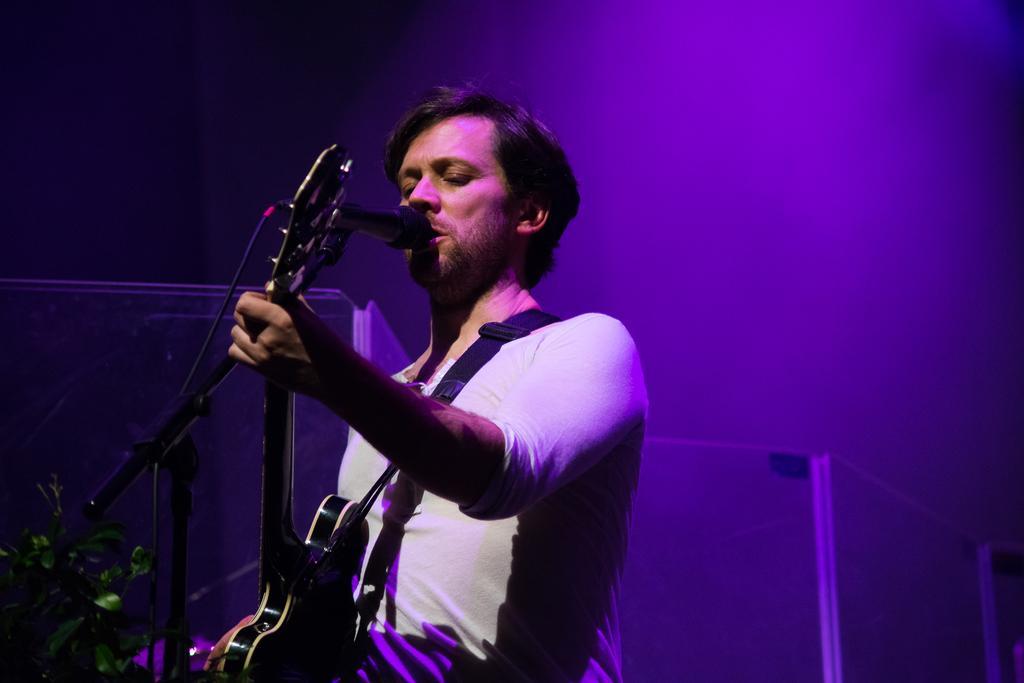How would you summarize this image in a sentence or two? In this picture a person is standing, singing and playing a guitar. 